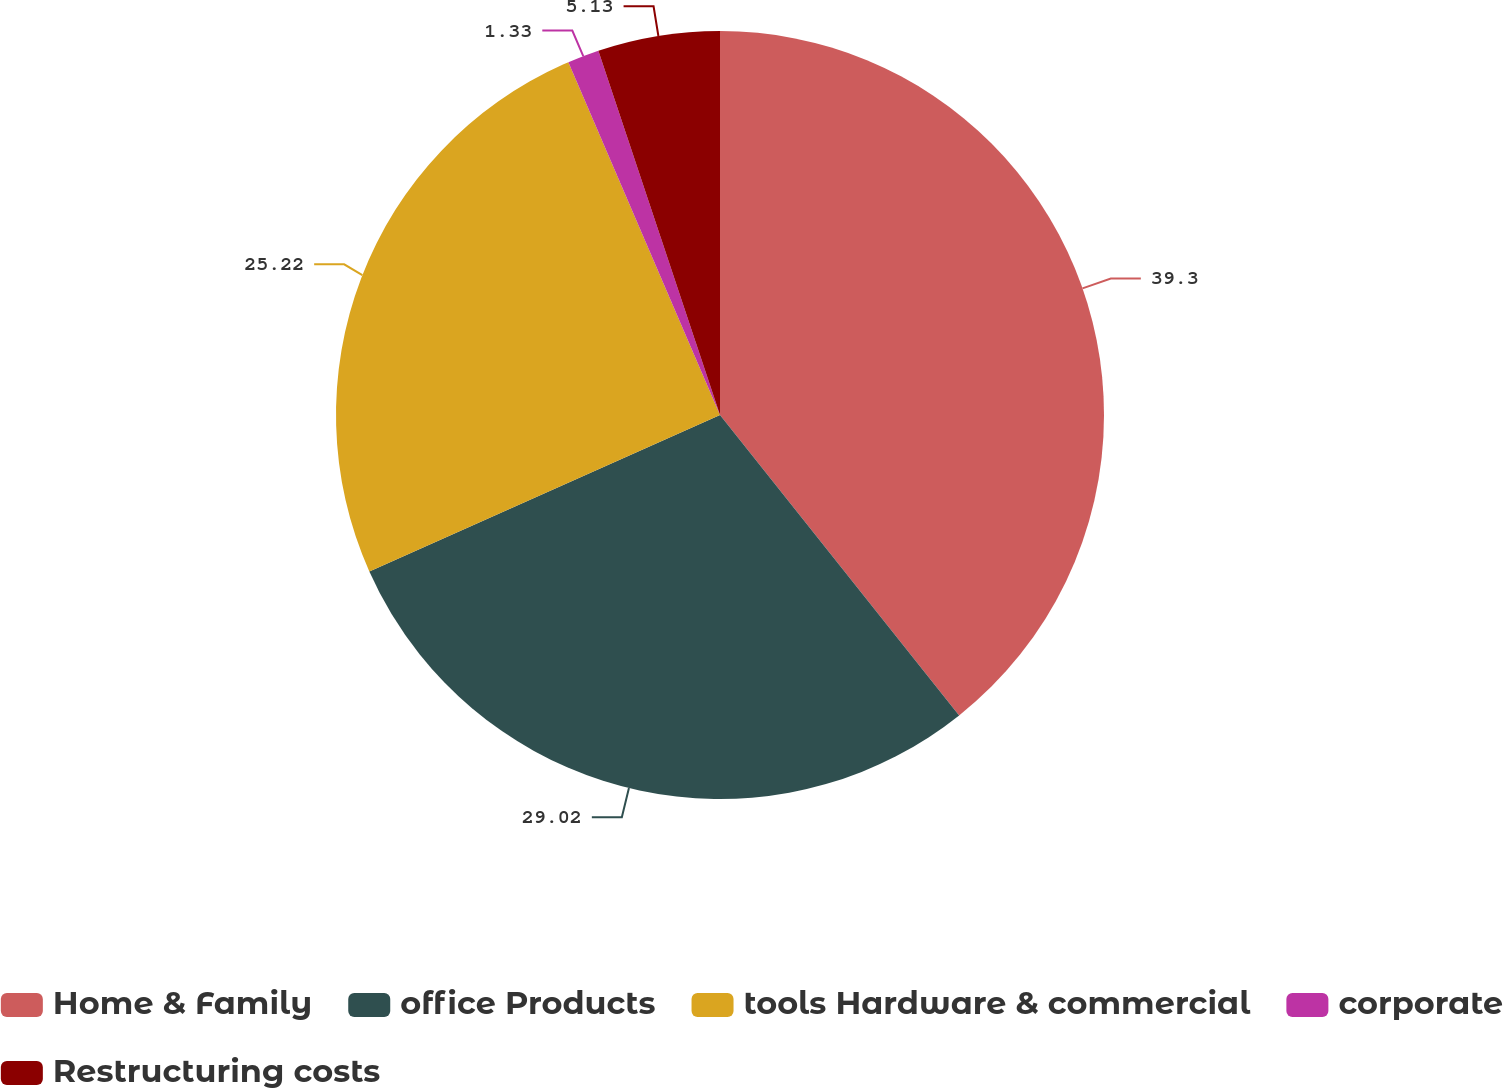Convert chart to OTSL. <chart><loc_0><loc_0><loc_500><loc_500><pie_chart><fcel>Home & Family<fcel>office Products<fcel>tools Hardware & commercial<fcel>corporate<fcel>Restructuring costs<nl><fcel>39.3%<fcel>29.02%<fcel>25.22%<fcel>1.33%<fcel>5.13%<nl></chart> 